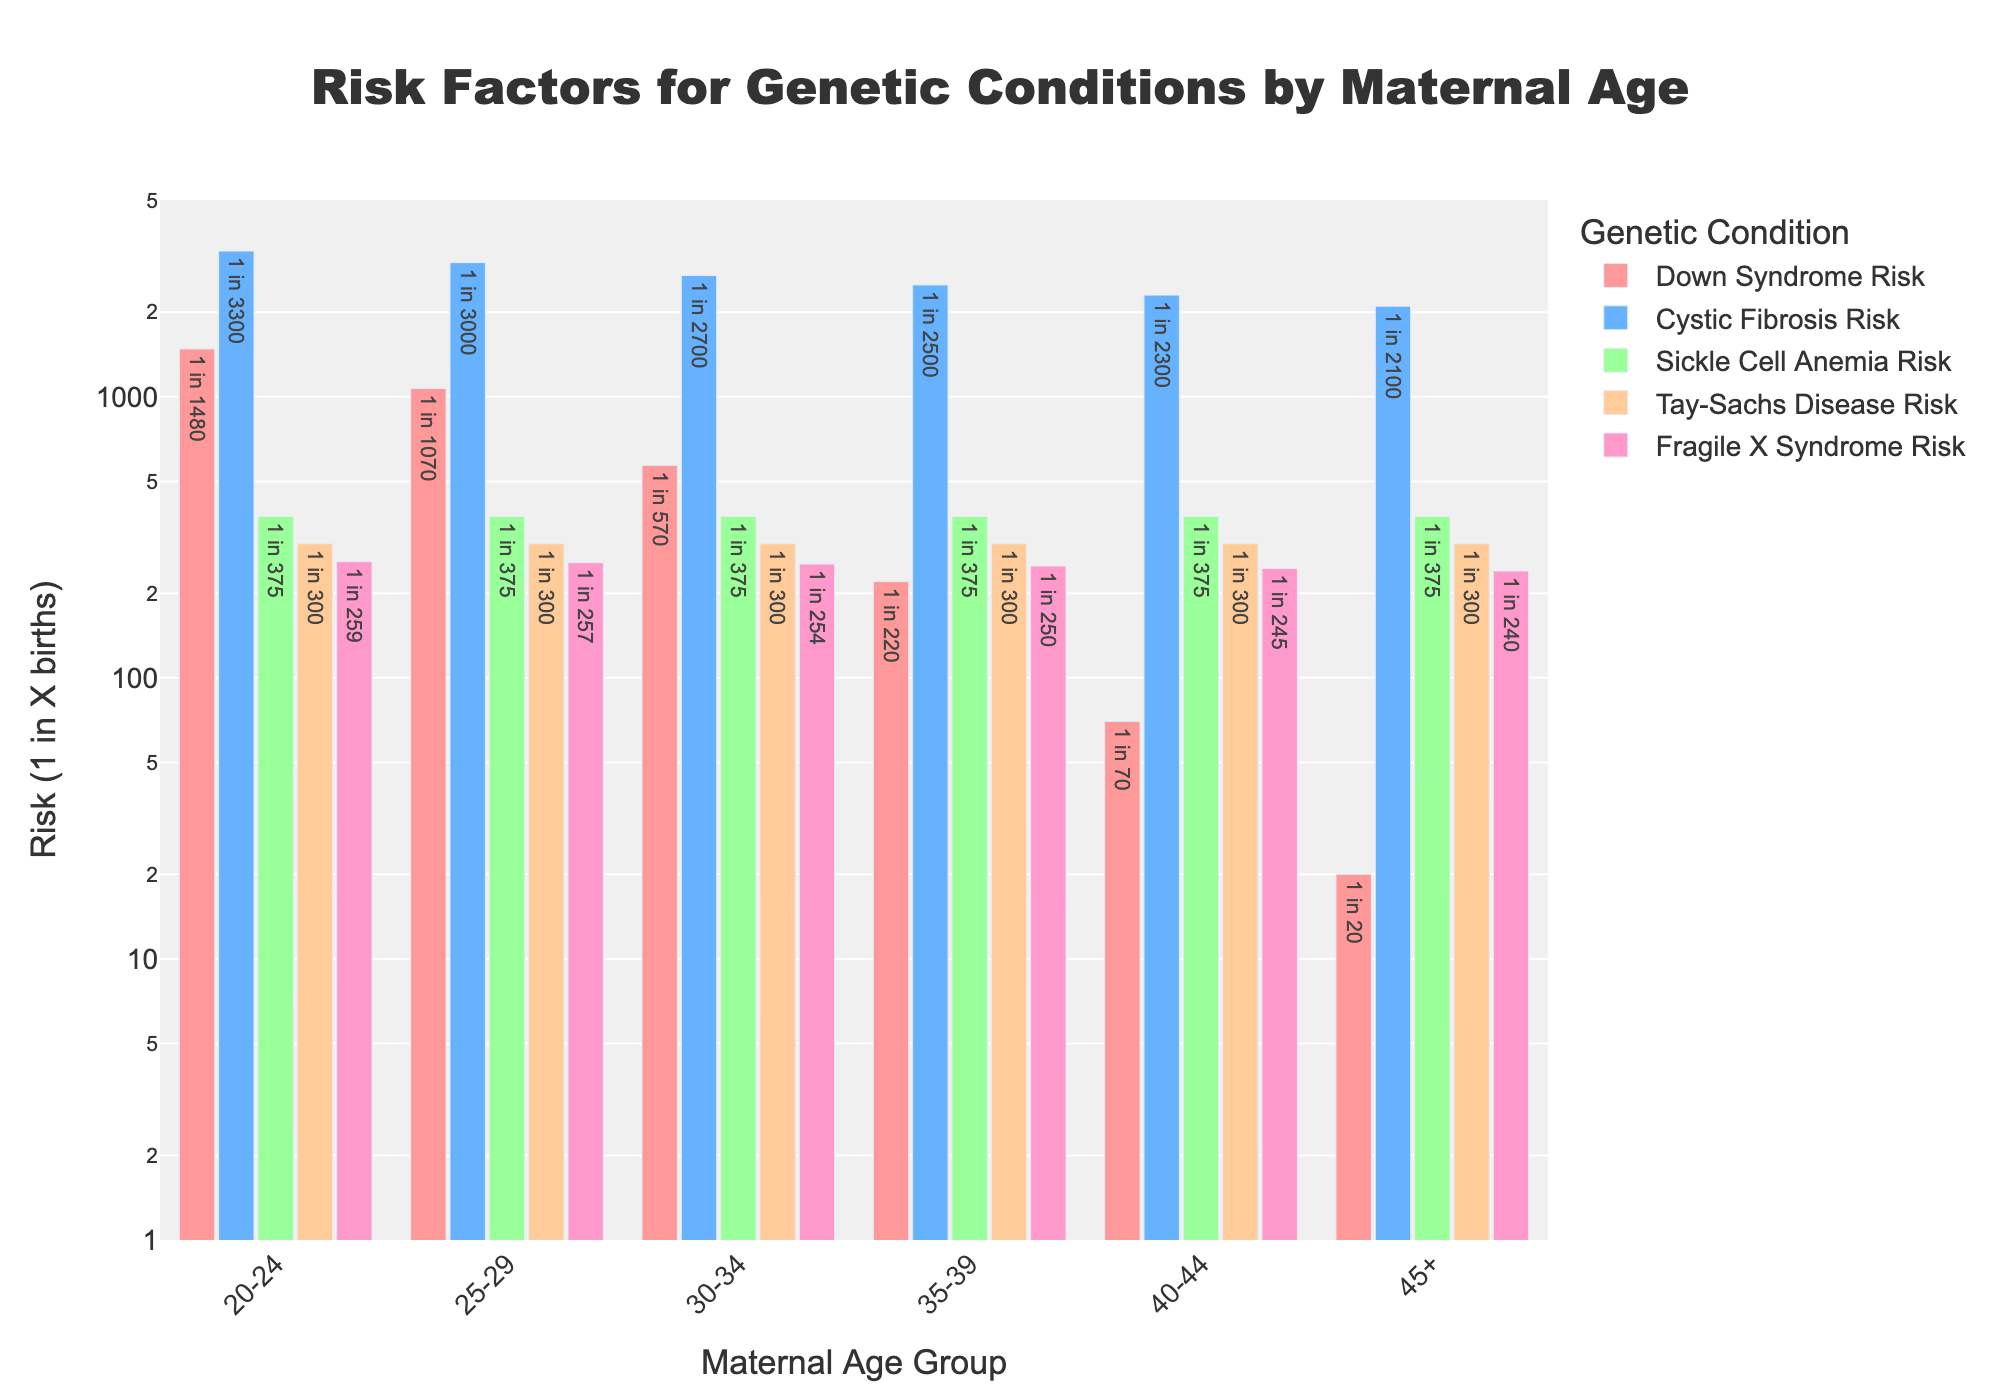What is the highest risk level for Down Syndrome among the maternal age groups? To find the highest risk level for Down Syndrome among the maternal age groups, look at the length of the bars representing Down Syndrome and identify the tallest one. The tallest bar is observed in the 45+ age group. The risk level shown is 1 in 20 births.
Answer: 1 in 20 Which maternal age group has the lowest risk for Cystic Fibrosis? Examine the bars representing Cystic Fibrosis risk and locate the shortest one. The shortest bar appears in the 20-24 age group. The risk level shown is 1 in 3300 births.
Answer: 20-24 How does the risk of Fragile X Syndrome change across all age groups? Observing the bars for Fragile X Syndrome across all age groups, they decrease slightly, from 1 in 259 in the 20-24 age group to 1 in 240 in the 45+ age group. The risk is generally decreasing slightly as maternal age increases.
Answer: Slightly decreases Compare the risk of Tay-Sachs Disease between the 20-24 and 45+ age groups. Look at the bar lengths for Tay-Sachs Disease risk in both age groups (20-24, 45+). Both bars are equal in length, indicating that the risk levels are the same. The shown risk level is 1 in 300 births.
Answer: Same Which genetic condition has the least variation in risk across all age groups? To determine which genetic condition has the least variation, compare the heights of each condition's bars across all age groups. The bars for Sickle Cell Anemia are of equal height across all age groups, indicating a consistent risk level of 1 in 375 births.
Answer: Sickle Cell Anemia What is the percentage difference in Down Syndrome risk between the 30-34 and 40-44 age groups? First, determine the Down Syndrome risk for both age groups: 1 in 570 for 30-34 and 1 in 70 for 40-44. Convert these to percentages (1/570 = 0.1754% and 1/70 = 1.4286%). Calculate the percentage difference: (1.4286% - 0.1754%) / 0.1754% * 100 = 714.8%.
Answer: 714.8% Which condition shows the most significant increase in risk from the 20-24 to 45+ age groups? Compare the bars for each condition from the 20-24 to the 45+ age groups and identify the condition with the most noticeable increase in bar height. Down Syndrome has the most significant increase, from 1 in 1480 to 1 in 20 births.
Answer: Down Syndrome What is the average risk of Cystic Fibrosis among all maternal age groups? To calculate the average risk: (3300 + 3000 + 2700 + 2500 + 2300 + 2100) / 6 = 2650. Thus, the average risk is approximately 1 in 2650 births.
Answer: 1 in 2650 How does the risk of Down Syndrome compare between the 25-29 and 35-39 age groups? Look at the bars for Down Syndrome risk for the 25-29 and 35-39 age groups. The risk for 25-29 is 1 in 1070, and for 35-39 is 1 in 220. The risk increases significantly when comparing these two age groups.
Answer: Increases significantly Which genetic condition shows a consistent risk across all age groups without any significant change? Examine the bars for each condition and identify which one remains consistent. The bars for Sickle Cell Anemia are equal in height across all age groups, showing no significant change in risk.
Answer: Sickle Cell Anemia 